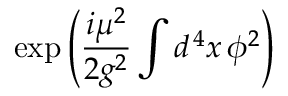<formula> <loc_0><loc_0><loc_500><loc_500>\exp \left ( { \frac { i \mu ^ { 2 } } { 2 g ^ { 2 } } } \int d ^ { \, 4 } x \, \phi ^ { 2 } \right )</formula> 